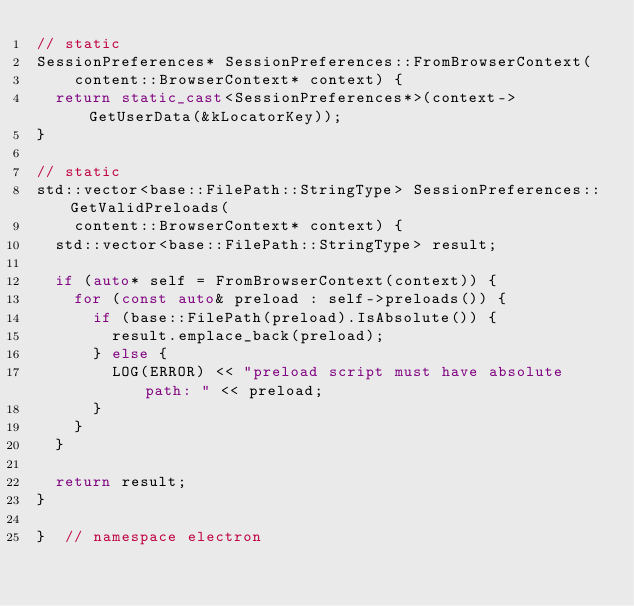Convert code to text. <code><loc_0><loc_0><loc_500><loc_500><_C++_>// static
SessionPreferences* SessionPreferences::FromBrowserContext(
    content::BrowserContext* context) {
  return static_cast<SessionPreferences*>(context->GetUserData(&kLocatorKey));
}

// static
std::vector<base::FilePath::StringType> SessionPreferences::GetValidPreloads(
    content::BrowserContext* context) {
  std::vector<base::FilePath::StringType> result;

  if (auto* self = FromBrowserContext(context)) {
    for (const auto& preload : self->preloads()) {
      if (base::FilePath(preload).IsAbsolute()) {
        result.emplace_back(preload);
      } else {
        LOG(ERROR) << "preload script must have absolute path: " << preload;
      }
    }
  }

  return result;
}

}  // namespace electron
</code> 